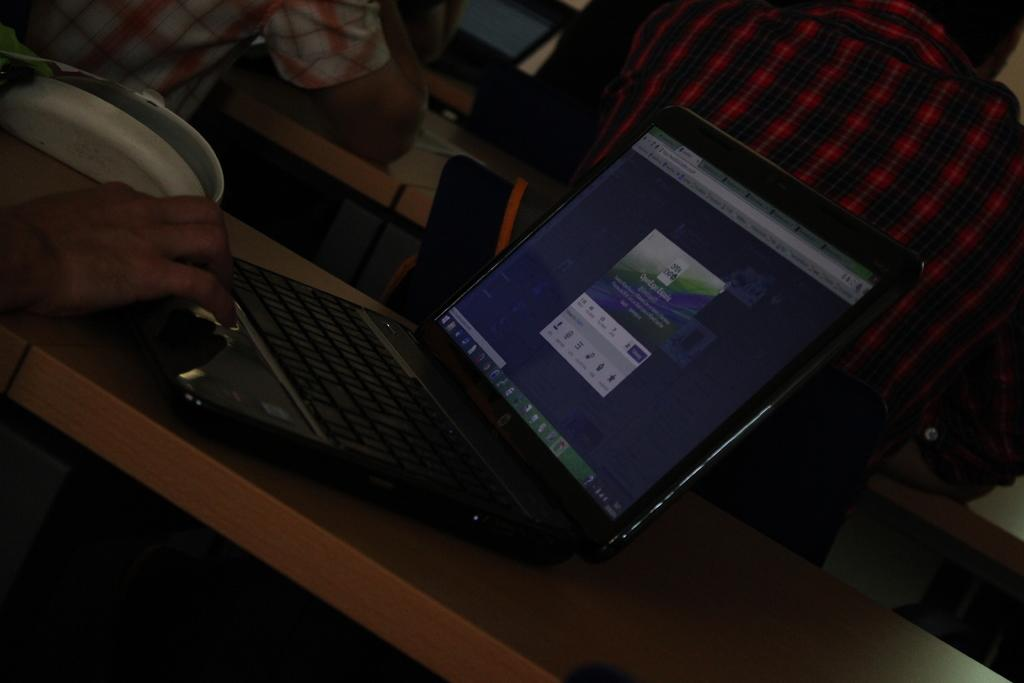How many people are sitting on the bench in the image? There are two persons sitting on a bench in the image. What can be seen on the table in the image? There is a laptop and an unspecified object on the table in the image. Can you describe any visible body parts of the persons in the image? A hand of a person is visible in the image. What type of vest is the doll wearing in the image? There is no doll present in the image, so it is not possible to determine what type of vest it might be wearing. 